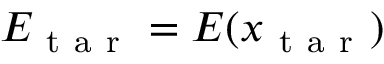<formula> <loc_0><loc_0><loc_500><loc_500>E _ { t a r } = E ( x _ { t a r } )</formula> 